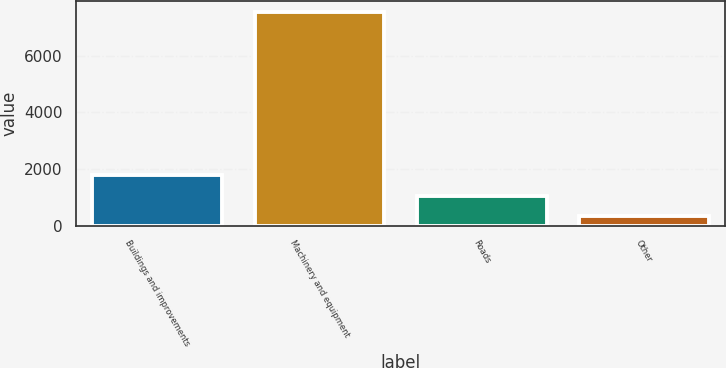<chart> <loc_0><loc_0><loc_500><loc_500><bar_chart><fcel>Buildings and improvements<fcel>Machinery and equipment<fcel>Roads<fcel>Other<nl><fcel>1777.2<fcel>7550<fcel>1055.6<fcel>334<nl></chart> 